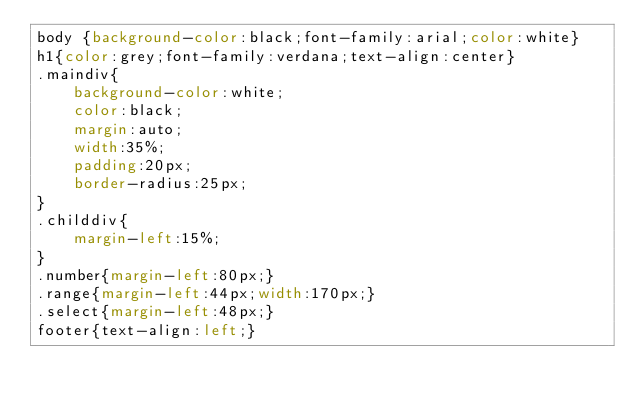<code> <loc_0><loc_0><loc_500><loc_500><_CSS_>body {background-color:black;font-family:arial;color:white}
h1{color:grey;font-family:verdana;text-align:center}
.maindiv{
    background-color:white;
    color:black;
    margin:auto;
    width:35%;
    padding:20px;
    border-radius:25px;
}
.childdiv{
    margin-left:15%;
}
.number{margin-left:80px;}
.range{margin-left:44px;width:170px;}
.select{margin-left:48px;}
footer{text-align:left;}
</code> 